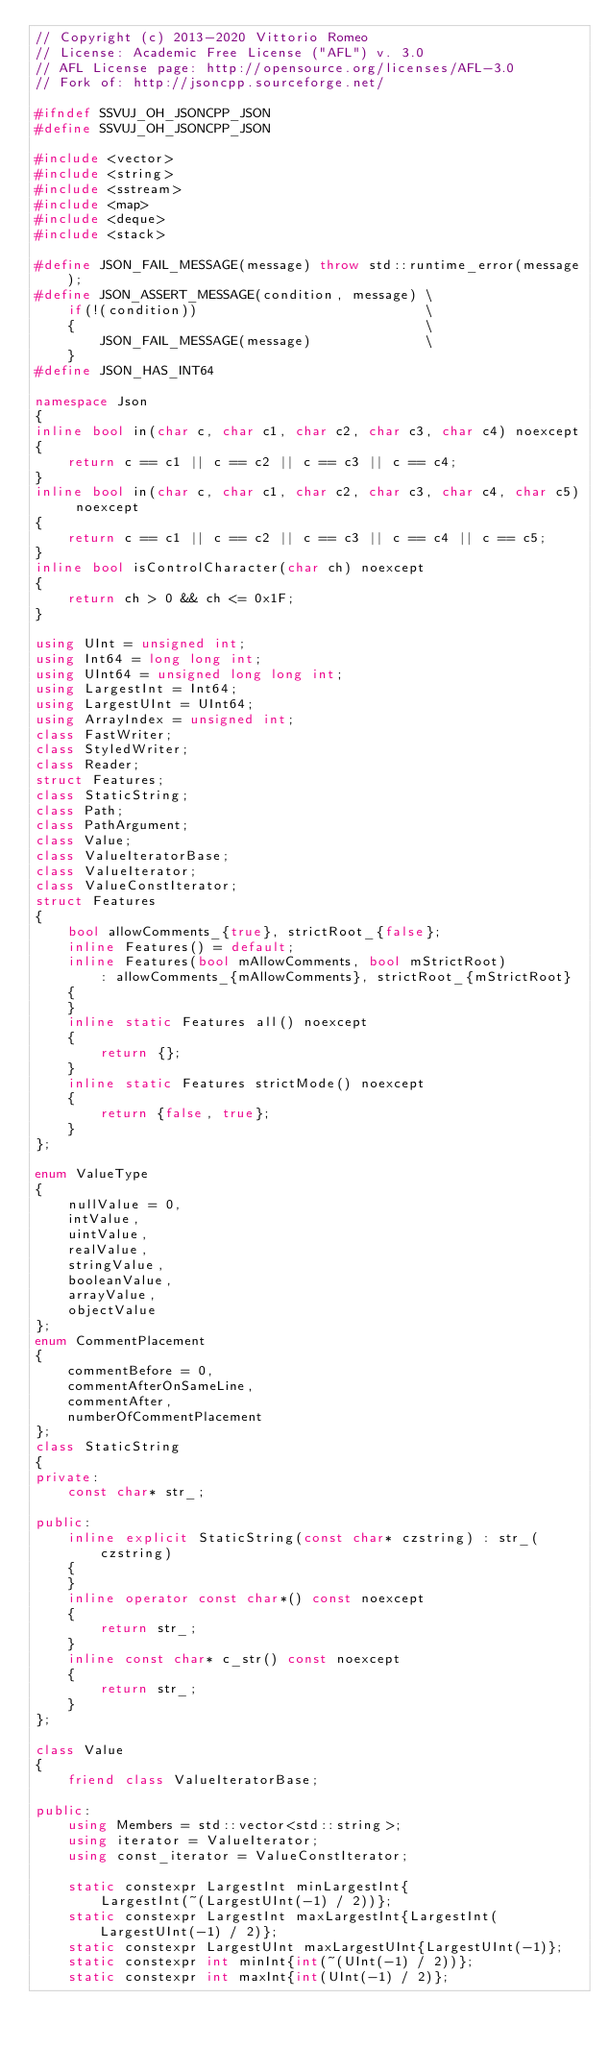Convert code to text. <code><loc_0><loc_0><loc_500><loc_500><_C++_>// Copyright (c) 2013-2020 Vittorio Romeo
// License: Academic Free License ("AFL") v. 3.0
// AFL License page: http://opensource.org/licenses/AFL-3.0
// Fork of: http://jsoncpp.sourceforge.net/

#ifndef SSVUJ_OH_JSONCPP_JSON
#define SSVUJ_OH_JSONCPP_JSON

#include <vector>
#include <string>
#include <sstream>
#include <map>
#include <deque>
#include <stack>

#define JSON_FAIL_MESSAGE(message) throw std::runtime_error(message);
#define JSON_ASSERT_MESSAGE(condition, message) \
    if(!(condition))                            \
    {                                           \
        JSON_FAIL_MESSAGE(message)              \
    }
#define JSON_HAS_INT64

namespace Json
{
inline bool in(char c, char c1, char c2, char c3, char c4) noexcept
{
    return c == c1 || c == c2 || c == c3 || c == c4;
}
inline bool in(char c, char c1, char c2, char c3, char c4, char c5) noexcept
{
    return c == c1 || c == c2 || c == c3 || c == c4 || c == c5;
}
inline bool isControlCharacter(char ch) noexcept
{
    return ch > 0 && ch <= 0x1F;
}

using UInt = unsigned int;
using Int64 = long long int;
using UInt64 = unsigned long long int;
using LargestInt = Int64;
using LargestUInt = UInt64;
using ArrayIndex = unsigned int;
class FastWriter;
class StyledWriter;
class Reader;
struct Features;
class StaticString;
class Path;
class PathArgument;
class Value;
class ValueIteratorBase;
class ValueIterator;
class ValueConstIterator;
struct Features
{
    bool allowComments_{true}, strictRoot_{false};
    inline Features() = default;
    inline Features(bool mAllowComments, bool mStrictRoot)
        : allowComments_{mAllowComments}, strictRoot_{mStrictRoot}
    {
    }
    inline static Features all() noexcept
    {
        return {};
    }
    inline static Features strictMode() noexcept
    {
        return {false, true};
    }
};

enum ValueType
{
    nullValue = 0,
    intValue,
    uintValue,
    realValue,
    stringValue,
    booleanValue,
    arrayValue,
    objectValue
};
enum CommentPlacement
{
    commentBefore = 0,
    commentAfterOnSameLine,
    commentAfter,
    numberOfCommentPlacement
};
class StaticString
{
private:
    const char* str_;

public:
    inline explicit StaticString(const char* czstring) : str_(czstring)
    {
    }
    inline operator const char*() const noexcept
    {
        return str_;
    }
    inline const char* c_str() const noexcept
    {
        return str_;
    }
};

class Value
{
    friend class ValueIteratorBase;

public:
    using Members = std::vector<std::string>;
    using iterator = ValueIterator;
    using const_iterator = ValueConstIterator;

    static constexpr LargestInt minLargestInt{
        LargestInt(~(LargestUInt(-1) / 2))};
    static constexpr LargestInt maxLargestInt{LargestInt(LargestUInt(-1) / 2)};
    static constexpr LargestUInt maxLargestUInt{LargestUInt(-1)};
    static constexpr int minInt{int(~(UInt(-1) / 2))};
    static constexpr int maxInt{int(UInt(-1) / 2)};</code> 